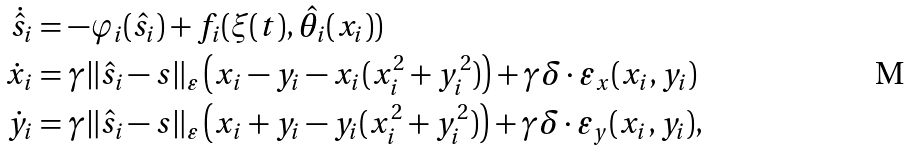Convert formula to latex. <formula><loc_0><loc_0><loc_500><loc_500>\dot { \hat { s } } _ { i } & = - \varphi _ { i } ( \hat { s } _ { i } ) + f _ { i } ( \xi ( t ) , \hat { \theta } _ { i } ( x _ { i } ) ) \\ \dot { x } _ { i } & = \gamma \| \hat { s } _ { i } - s \| _ { \varepsilon } \left ( x _ { i } - y _ { i } - x _ { i } ( x _ { i } ^ { 2 } + y _ { i } ^ { 2 } ) \right ) + \gamma \delta \cdot \varepsilon _ { x } ( x _ { i } , y _ { i } ) \\ \dot { y } _ { i } & = \gamma \| \hat { s } _ { i } - s \| _ { \varepsilon } \left ( x _ { i } + y _ { i } - y _ { i } ( x _ { i } ^ { 2 } + y _ { i } ^ { 2 } ) \right ) + \gamma \delta \cdot \varepsilon _ { y } ( x _ { i } , y _ { i } ) ,</formula> 